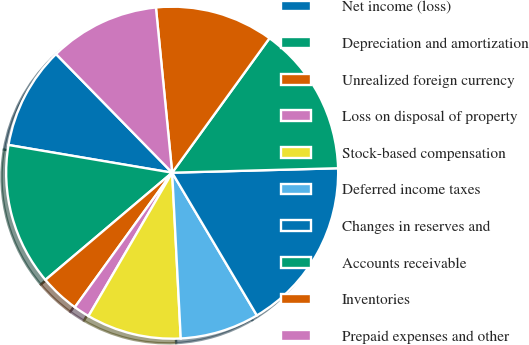Convert chart to OTSL. <chart><loc_0><loc_0><loc_500><loc_500><pie_chart><fcel>Net income (loss)<fcel>Depreciation and amortization<fcel>Unrealized foreign currency<fcel>Loss on disposal of property<fcel>Stock-based compensation<fcel>Deferred income taxes<fcel>Changes in reserves and<fcel>Accounts receivable<fcel>Inventories<fcel>Prepaid expenses and other<nl><fcel>10.0%<fcel>13.84%<fcel>3.86%<fcel>1.56%<fcel>9.23%<fcel>7.7%<fcel>16.9%<fcel>14.6%<fcel>11.53%<fcel>10.77%<nl></chart> 